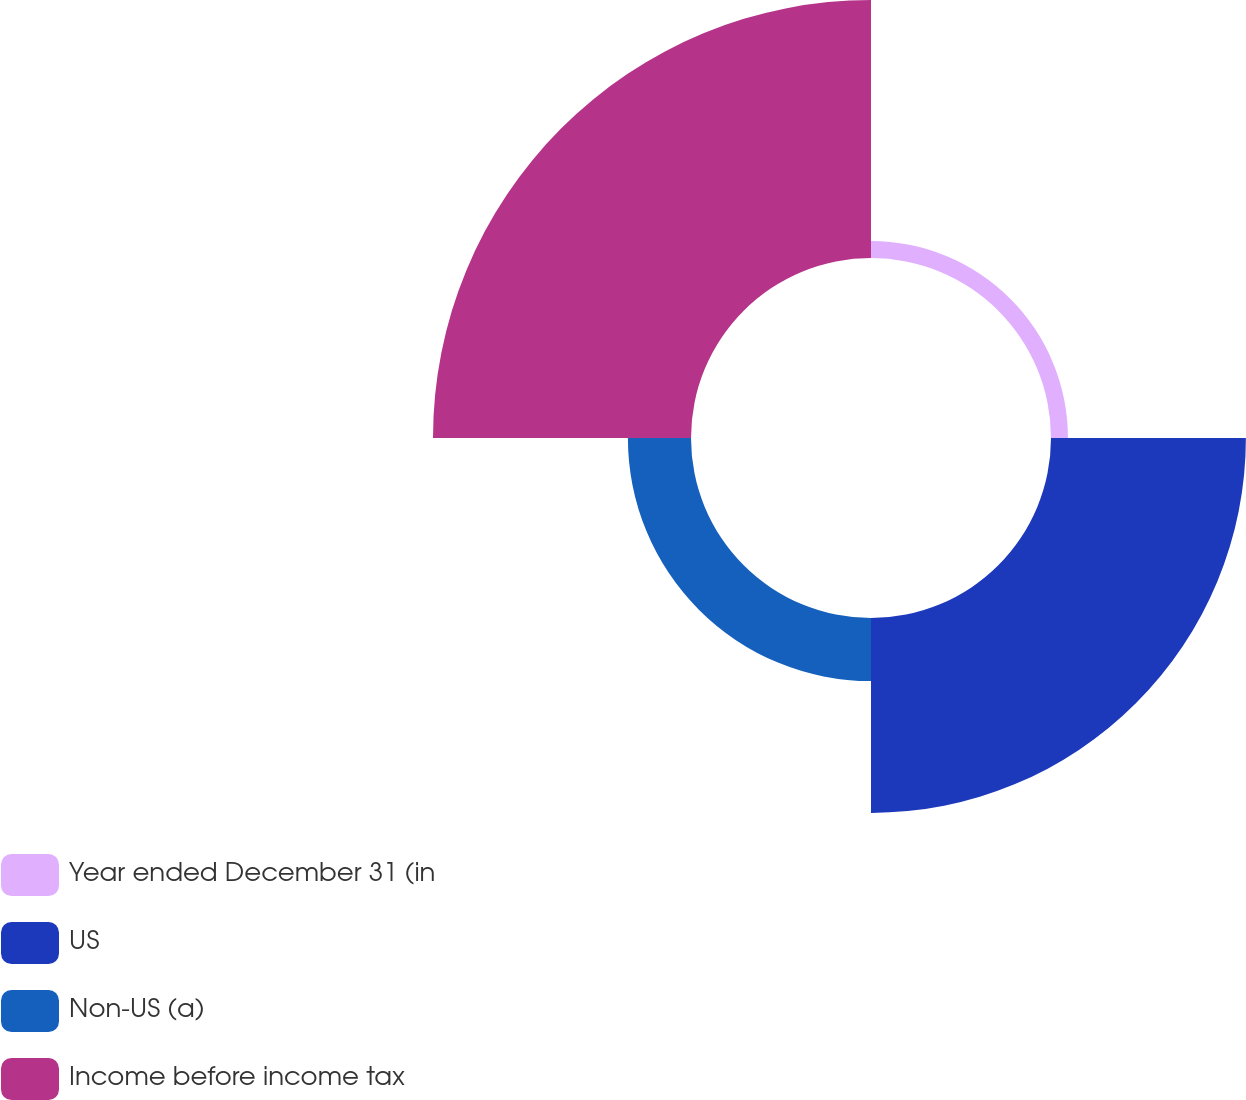Convert chart. <chart><loc_0><loc_0><loc_500><loc_500><pie_chart><fcel>Year ended December 31 (in<fcel>US<fcel>Non-US (a)<fcel>Income before income tax<nl><fcel>3.18%<fcel>36.57%<fcel>11.84%<fcel>48.41%<nl></chart> 